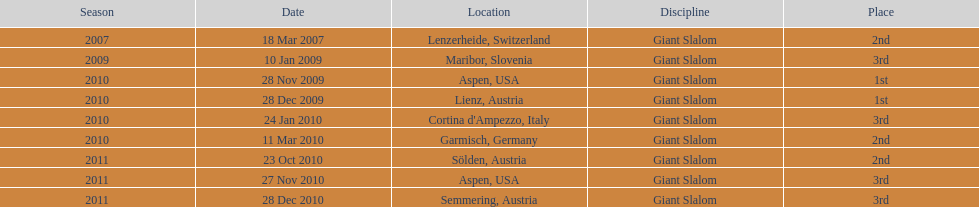Parse the table in full. {'header': ['Season', 'Date', 'Location', 'Discipline', 'Place'], 'rows': [['2007', '18 Mar 2007', 'Lenzerheide, Switzerland', 'Giant Slalom', '2nd'], ['2009', '10 Jan 2009', 'Maribor, Slovenia', 'Giant Slalom', '3rd'], ['2010', '28 Nov 2009', 'Aspen, USA', 'Giant Slalom', '1st'], ['2010', '28 Dec 2009', 'Lienz, Austria', 'Giant Slalom', '1st'], ['2010', '24 Jan 2010', "Cortina d'Ampezzo, Italy", 'Giant Slalom', '3rd'], ['2010', '11 Mar 2010', 'Garmisch, Germany', 'Giant Slalom', '2nd'], ['2011', '23 Oct 2010', 'Sölden, Austria', 'Giant Slalom', '2nd'], ['2011', '27 Nov 2010', 'Aspen, USA', 'Giant Slalom', '3rd'], ['2011', '28 Dec 2010', 'Semmering, Austria', 'Giant Slalom', '3rd']]} The last race completion location was not 1st, but what alternative position? 3rd. 